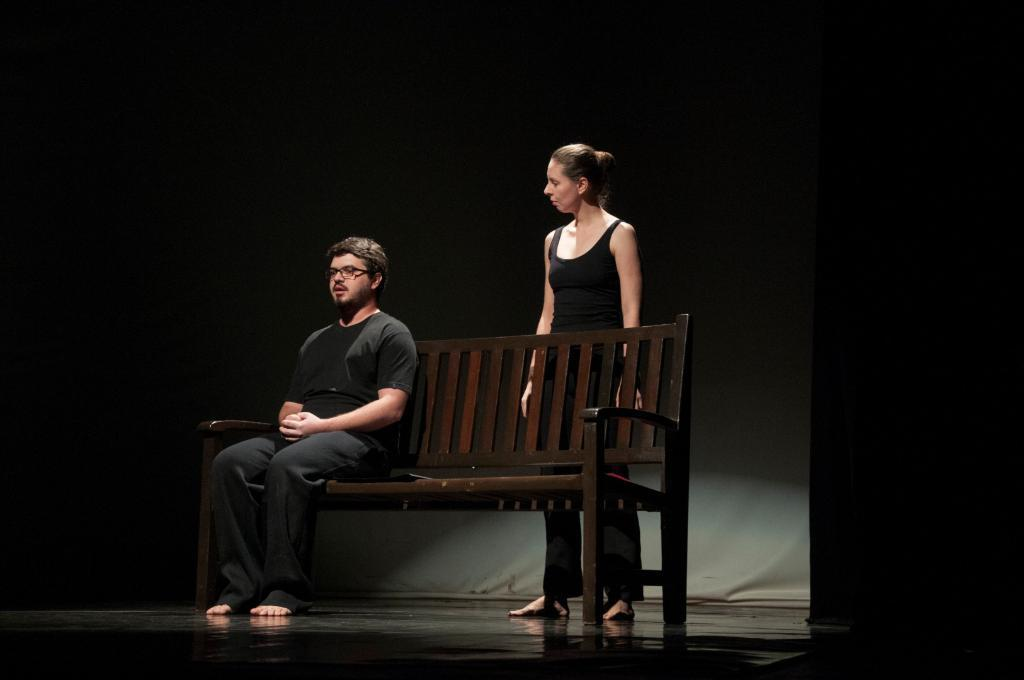What is the man in the image doing? The man is sitting on a bench in the image. What is the woman in the image doing? The woman is standing in the image. What is the woman's focus in the image? The woman is looking at the man in the image. How many babies are crawling in the middle of the image? There are no babies present in the image. What type of crook is visible in the image? There is no crook present in the image. 